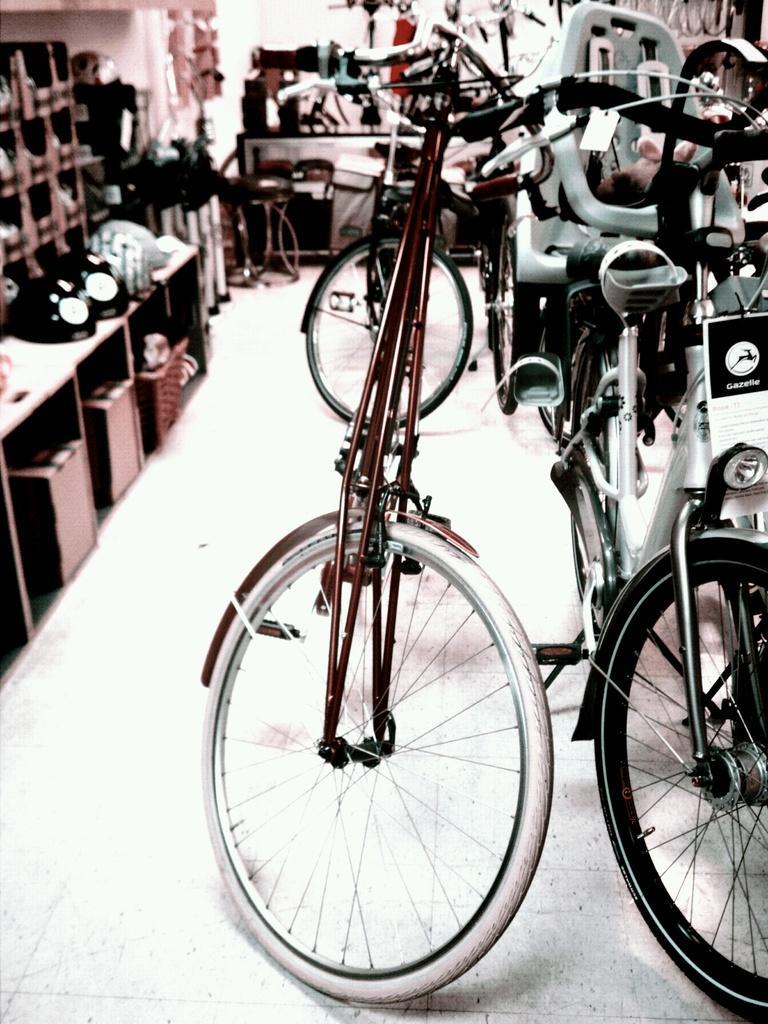Can you describe this image briefly? On the right side, there are bicycles parked on the floor. On the left side, there are boxes and other objects arranged on the shelves. In the background, there is white wall and there are other objects. 